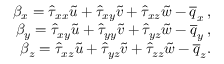<formula> <loc_0><loc_0><loc_500><loc_500>\begin{array} { r } { \beta _ { x } = \hat { \tau } _ { x x } \tilde { u } + \hat { \tau } _ { x y } \tilde { v } + \hat { \tau } _ { x z } \tilde { w } - \overline { q } _ { x } \, , } \\ { \beta _ { y } = \hat { \tau } _ { x y } \tilde { u } + \hat { \tau } _ { y y } \tilde { v } + \hat { \tau } _ { y z } \tilde { w } - \overline { q } _ { y } \, , } \\ { \beta _ { z } = \hat { \tau } _ { x z } \tilde { u } + \hat { \tau } _ { y z } \tilde { v } + \hat { \tau } _ { z z } \tilde { w } - \overline { q } _ { z } . } \end{array}</formula> 